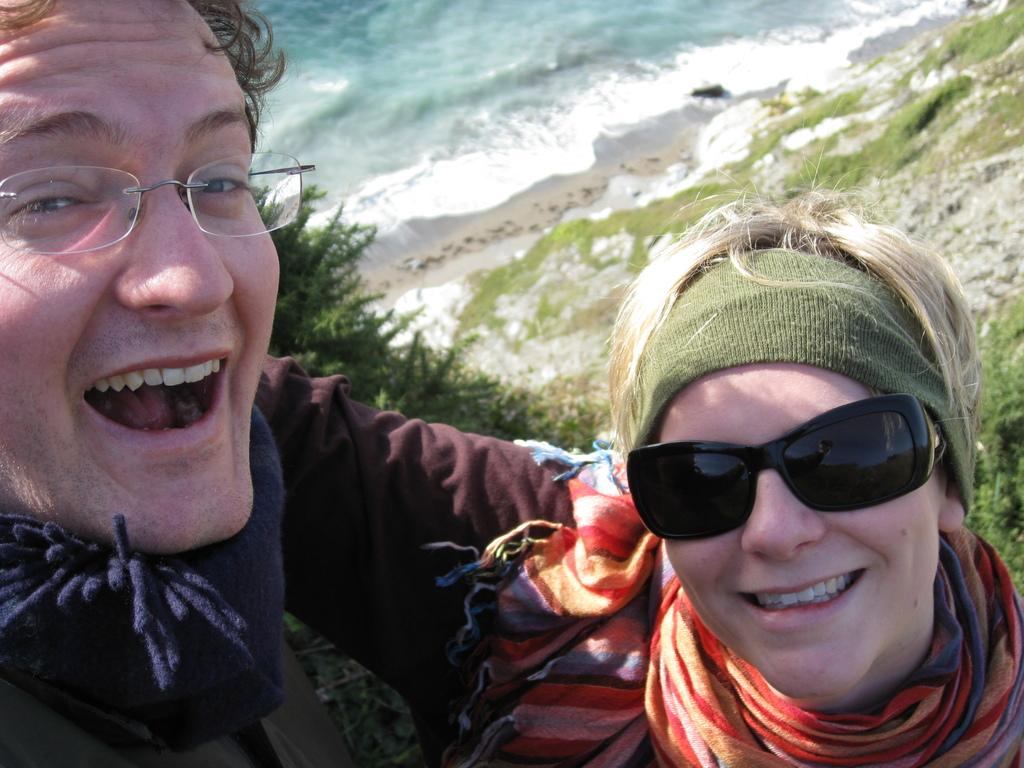How many people are in the image? There are two persons in the image. What is the facial expression of the persons in the image? The persons are smiling. What can be seen on the left side of the image? There is a tree on the left side of the image. What is visible in the background of the image? There is water visible in the background of the image. What type of vegetation is on the right side of the image? There are plants on the right side of the image. What type of twig is the person holding in the image? There is no twig present in the image. What suggestion is being made by the person on the right side of the image? There is no suggestion being made in the image, as it only shows two people smiling. 